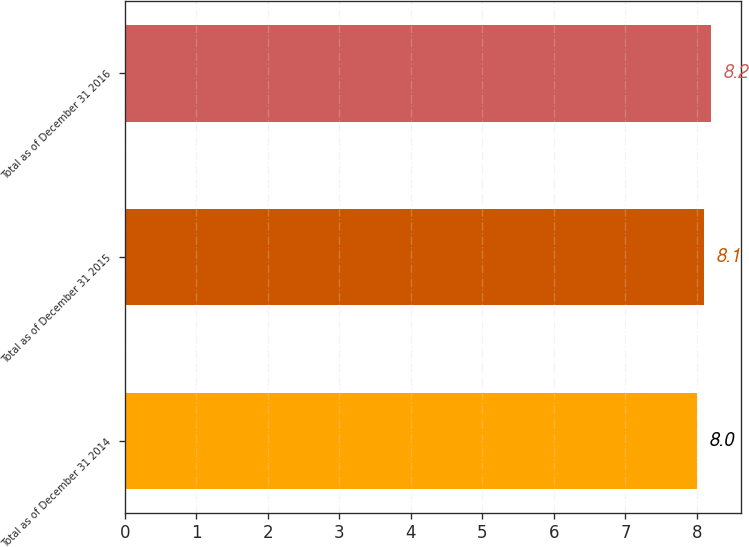Convert chart. <chart><loc_0><loc_0><loc_500><loc_500><bar_chart><fcel>Total as of December 31 2014<fcel>Total as of December 31 2015<fcel>Total as of December 31 2016<nl><fcel>8<fcel>8.1<fcel>8.2<nl></chart> 